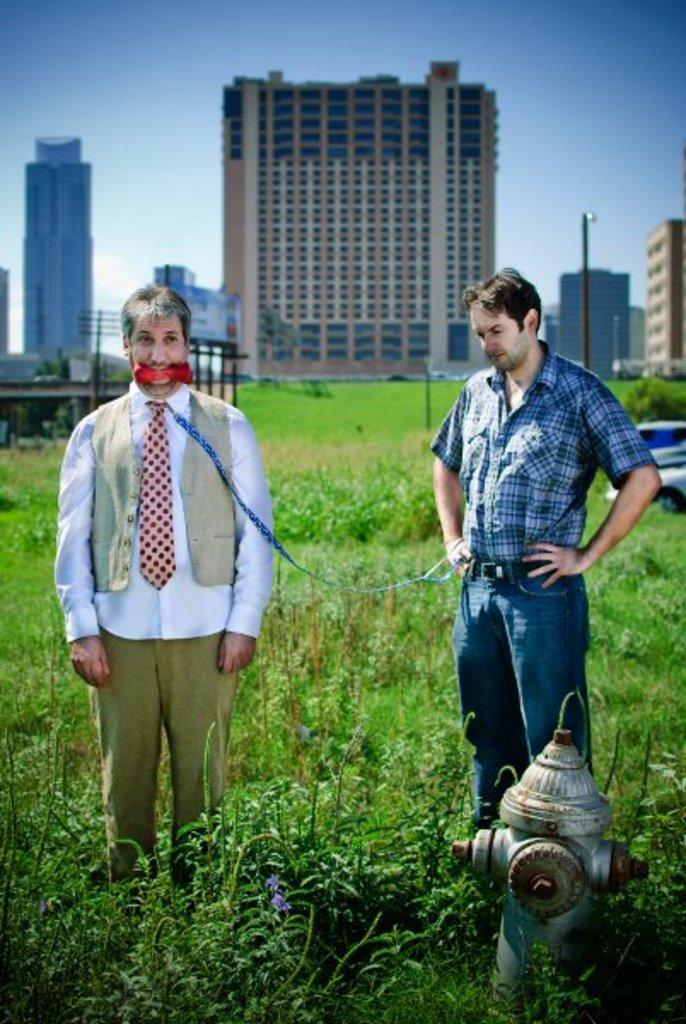How many people are in the image? There are two people standing in the center of the image. What is located on the right side of the image? There is a hydrant on the right side of the image. What type of vegetation is at the bottom of the image? There is grass at the bottom of the image. What can be seen in the background of the image? There are buildings, poles, and the sky visible in the background of the image. What type of wool is being spun by the creature in the image? There is no creature present in the image, and therefore no wool-spinning activity can be observed. How many cakes are being served on the grass in the image? There are no cakes present in the image; the grass is only mentioned as a type of vegetation at the bottom of the image. 